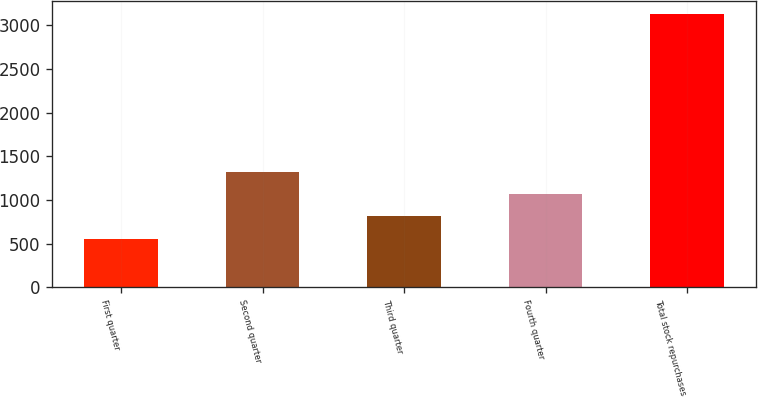<chart> <loc_0><loc_0><loc_500><loc_500><bar_chart><fcel>First quarter<fcel>Second quarter<fcel>Third quarter<fcel>Fourth quarter<fcel>Total stock repurchases<nl><fcel>555<fcel>1326.3<fcel>812.1<fcel>1069.2<fcel>3126<nl></chart> 